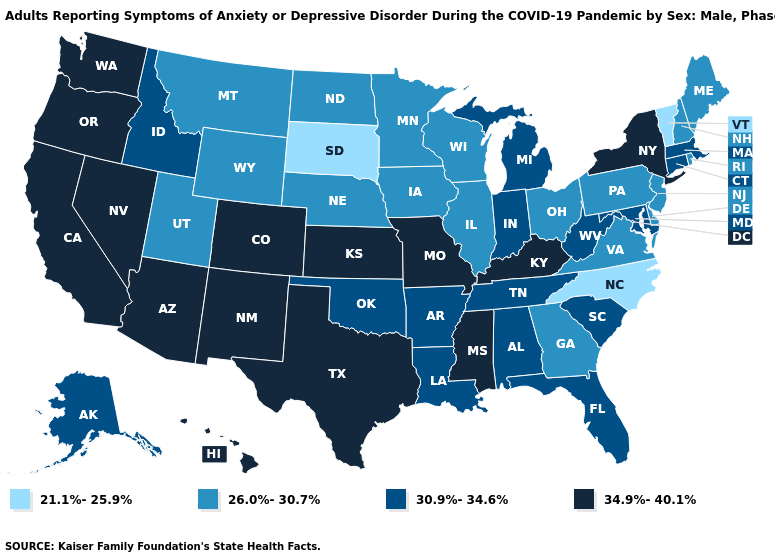What is the value of Pennsylvania?
Give a very brief answer. 26.0%-30.7%. Does New York have the same value as Montana?
Give a very brief answer. No. What is the value of Tennessee?
Be succinct. 30.9%-34.6%. Name the states that have a value in the range 34.9%-40.1%?
Concise answer only. Arizona, California, Colorado, Hawaii, Kansas, Kentucky, Mississippi, Missouri, Nevada, New Mexico, New York, Oregon, Texas, Washington. How many symbols are there in the legend?
Concise answer only. 4. What is the value of Kansas?
Quick response, please. 34.9%-40.1%. Does the first symbol in the legend represent the smallest category?
Be succinct. Yes. What is the value of New Mexico?
Write a very short answer. 34.9%-40.1%. What is the lowest value in the USA?
Answer briefly. 21.1%-25.9%. Among the states that border Montana , which have the lowest value?
Write a very short answer. South Dakota. What is the value of Massachusetts?
Concise answer only. 30.9%-34.6%. Does the first symbol in the legend represent the smallest category?
Write a very short answer. Yes. Name the states that have a value in the range 34.9%-40.1%?
Write a very short answer. Arizona, California, Colorado, Hawaii, Kansas, Kentucky, Mississippi, Missouri, Nevada, New Mexico, New York, Oregon, Texas, Washington. Is the legend a continuous bar?
Answer briefly. No. 